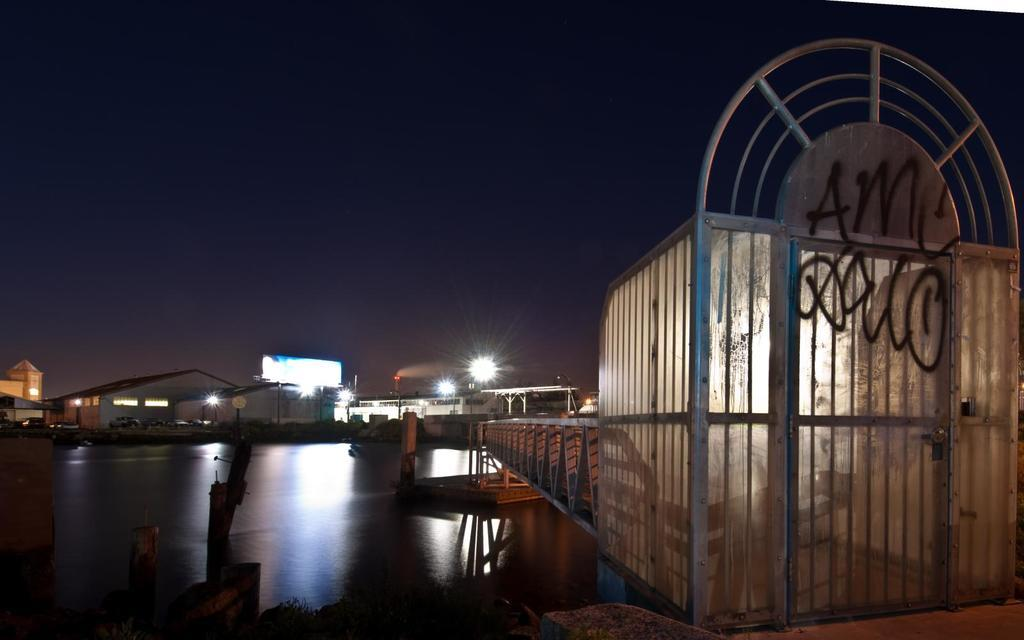What type of structure is present in the image? There is a gate with a door in the image. What can be seen crossing over the water in the image? There is a bridge in the image. What is visible in the image besides the gate and bridge? There is water visible in the image, as well as objects, sheds, lights, and the sky in the background. How many passengers are on the pie in the image? There is no pie present in the image, and therefore no passengers can be found on it. 